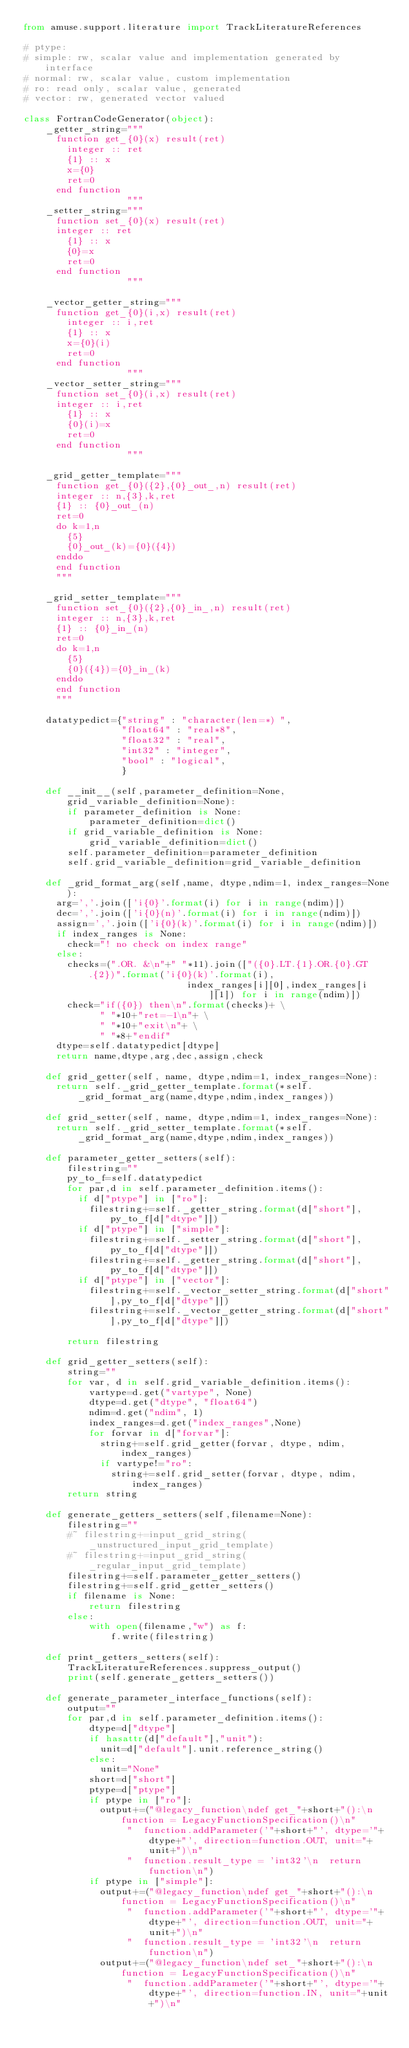Convert code to text. <code><loc_0><loc_0><loc_500><loc_500><_Python_>from amuse.support.literature import TrackLiteratureReferences    

# ptype:
# simple: rw, scalar value and implementation generated by interface
# normal: rw, scalar value, custom implementation 
# ro: read only, scalar value, generated 
# vector: rw, generated vector valued

class FortranCodeGenerator(object):
    _getter_string="""
      function get_{0}(x) result(ret)
        integer :: ret
        {1} :: x
        x={0}
        ret=0
      end function
                   """
    _setter_string="""
      function set_{0}(x) result(ret)
      integer :: ret
        {1} :: x
        {0}=x
        ret=0
      end function
                   """
    
    _vector_getter_string="""
      function get_{0}(i,x) result(ret)
        integer :: i,ret
        {1} :: x
        x={0}(i)
        ret=0
      end function
                   """
    _vector_setter_string="""
      function set_{0}(i,x) result(ret)
      integer :: i,ret
        {1} :: x
        {0}(i)=x
        ret=0
      end function
                   """

    _grid_getter_template="""
      function get_{0}({2},{0}_out_,n) result(ret)
      integer :: n,{3},k,ret
      {1} :: {0}_out_(n)
      ret=0
      do k=1,n
        {5}
        {0}_out_(k)={0}({4})
      enddo
      end function
      """

    _grid_setter_template="""
      function set_{0}({2},{0}_in_,n) result(ret)
      integer :: n,{3},k,ret
      {1} :: {0}_in_(n)
      ret=0
      do k=1,n
        {5}
        {0}({4})={0}_in_(k)
      enddo
      end function
      """    
    
    datatypedict={"string" : "character(len=*) ", 
                  "float64" : "real*8",
                  "float32" : "real",
                  "int32" : "integer",
                  "bool" : "logical",
                  }

    def __init__(self,parameter_definition=None, grid_variable_definition=None):
        if parameter_definition is None:
            parameter_definition=dict()
        if grid_variable_definition is None:
            grid_variable_definition=dict()
        self.parameter_definition=parameter_definition
        self.grid_variable_definition=grid_variable_definition

    def _grid_format_arg(self,name, dtype,ndim=1, index_ranges=None):
      arg=','.join(['i{0}'.format(i) for i in range(ndim)]) 
      dec=','.join(['i{0}(n)'.format(i) for i in range(ndim)])
      assign=','.join(['i{0}(k)'.format(i) for i in range(ndim)])
      if index_ranges is None:
        check="! no check on index range"
      else:
        checks=(".OR. &\n"+" "*11).join(["({0}.LT.{1}.OR.{0}.GT.{2})".format('i{0}(k)'.format(i), 
                              index_ranges[i][0],index_ranges[i][1]) for i in range(ndim)]) 
        check="if({0}) then\n".format(checks)+ \
              " "*10+"ret=-1\n"+ \
              " "*10+"exit\n"+ \
              " "*8+"endif"              
      dtype=self.datatypedict[dtype]
      return name,dtype,arg,dec,assign,check
    
    def grid_getter(self, name, dtype,ndim=1, index_ranges=None):
      return self._grid_getter_template.format(*self._grid_format_arg(name,dtype,ndim,index_ranges))

    def grid_setter(self, name, dtype,ndim=1, index_ranges=None):
      return self._grid_setter_template.format(*self._grid_format_arg(name,dtype,ndim,index_ranges))

    def parameter_getter_setters(self):
        filestring=""
        py_to_f=self.datatypedict
        for par,d in self.parameter_definition.items():
          if d["ptype"] in ["ro"]:
            filestring+=self._getter_string.format(d["short"],py_to_f[d["dtype"]])
          if d["ptype"] in ["simple"]:
            filestring+=self._setter_string.format(d["short"],py_to_f[d["dtype"]])
            filestring+=self._getter_string.format(d["short"],py_to_f[d["dtype"]])
          if d["ptype"] in ["vector"]:
            filestring+=self._vector_setter_string.format(d["short"],py_to_f[d["dtype"]])
            filestring+=self._vector_getter_string.format(d["short"],py_to_f[d["dtype"]])
    
        return filestring

    def grid_getter_setters(self):
        string=""
        for var, d in self.grid_variable_definition.items():
            vartype=d.get("vartype", None)
            dtype=d.get("dtype", "float64")
            ndim=d.get("ndim", 1)
            index_ranges=d.get("index_ranges",None)
            for forvar in d["forvar"]:
              string+=self.grid_getter(forvar, dtype, ndim, index_ranges)
              if vartype!="ro":
                string+=self.grid_setter(forvar, dtype, ndim, index_ranges)
        return string

    def generate_getters_setters(self,filename=None):
        filestring=""
        #~ filestring+=input_grid_string(_unstructured_input_grid_template)
        #~ filestring+=input_grid_string(_regular_input_grid_template)
        filestring+=self.parameter_getter_setters()
        filestring+=self.grid_getter_setters()
        if filename is None:
            return filestring
        else:
            with open(filename,"w") as f:
                f.write(filestring)

    def print_getters_setters(self):
        TrackLiteratureReferences.suppress_output()
        print(self.generate_getters_setters())

    def generate_parameter_interface_functions(self):
        output=""
        for par,d in self.parameter_definition.items():
            dtype=d["dtype"]
            if hasattr(d["default"],"unit"):
              unit=d["default"].unit.reference_string()
            else:
              unit="None"
            short=d["short"]
            ptype=d["ptype"]
            if ptype in ["ro"]:
              output+=("@legacy_function\ndef get_"+short+"():\n  function = LegacyFunctionSpecification()\n"
                   "  function.addParameter('"+short+"', dtype='"+dtype+"', direction=function.OUT, unit="+unit+")\n"
                   "  function.result_type = 'int32'\n  return function\n")
            if ptype in ["simple"]:
              output+=("@legacy_function\ndef get_"+short+"():\n  function = LegacyFunctionSpecification()\n"
                   "  function.addParameter('"+short+"', dtype='"+dtype+"', direction=function.OUT, unit="+unit+")\n"
                   "  function.result_type = 'int32'\n  return function\n")
              output+=("@legacy_function\ndef set_"+short+"():\n  function = LegacyFunctionSpecification()\n"
                   "  function.addParameter('"+short+"', dtype='"+dtype+"', direction=function.IN, unit="+unit+")\n"</code> 